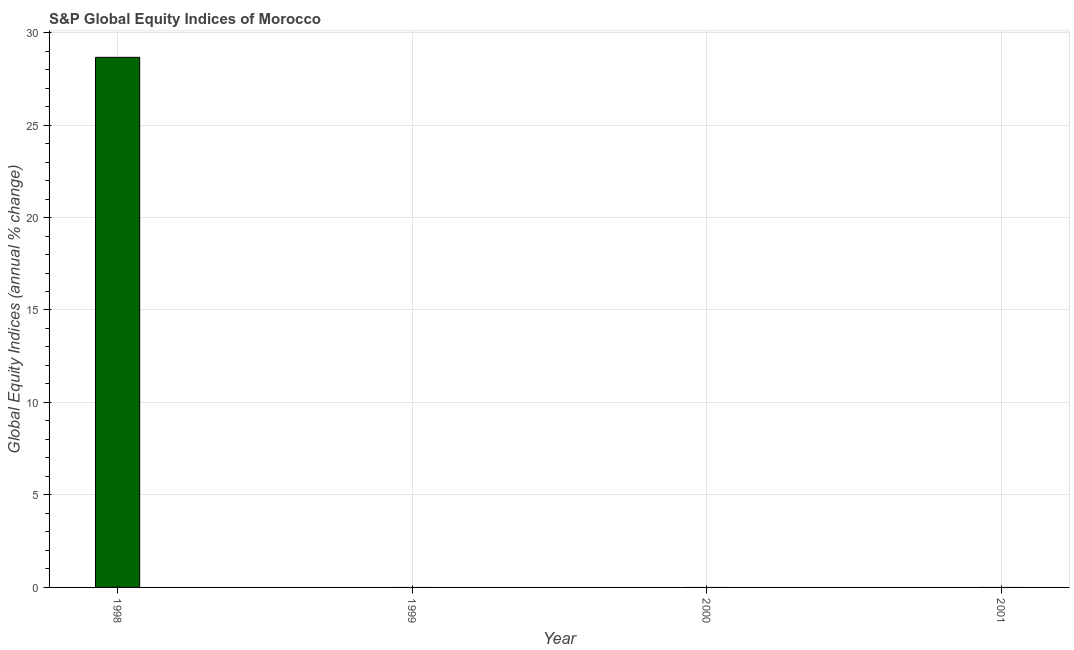Does the graph contain any zero values?
Keep it short and to the point. Yes. What is the title of the graph?
Your response must be concise. S&P Global Equity Indices of Morocco. What is the label or title of the X-axis?
Provide a succinct answer. Year. What is the label or title of the Y-axis?
Your response must be concise. Global Equity Indices (annual % change). What is the s&p global equity indices in 1998?
Make the answer very short. 28.66. Across all years, what is the maximum s&p global equity indices?
Your answer should be compact. 28.66. In which year was the s&p global equity indices maximum?
Give a very brief answer. 1998. What is the sum of the s&p global equity indices?
Provide a short and direct response. 28.66. What is the average s&p global equity indices per year?
Ensure brevity in your answer.  7.17. What is the median s&p global equity indices?
Ensure brevity in your answer.  0. In how many years, is the s&p global equity indices greater than 29 %?
Offer a terse response. 0. What is the difference between the highest and the lowest s&p global equity indices?
Your answer should be compact. 28.66. How many bars are there?
Give a very brief answer. 1. What is the Global Equity Indices (annual % change) of 1998?
Give a very brief answer. 28.66. 